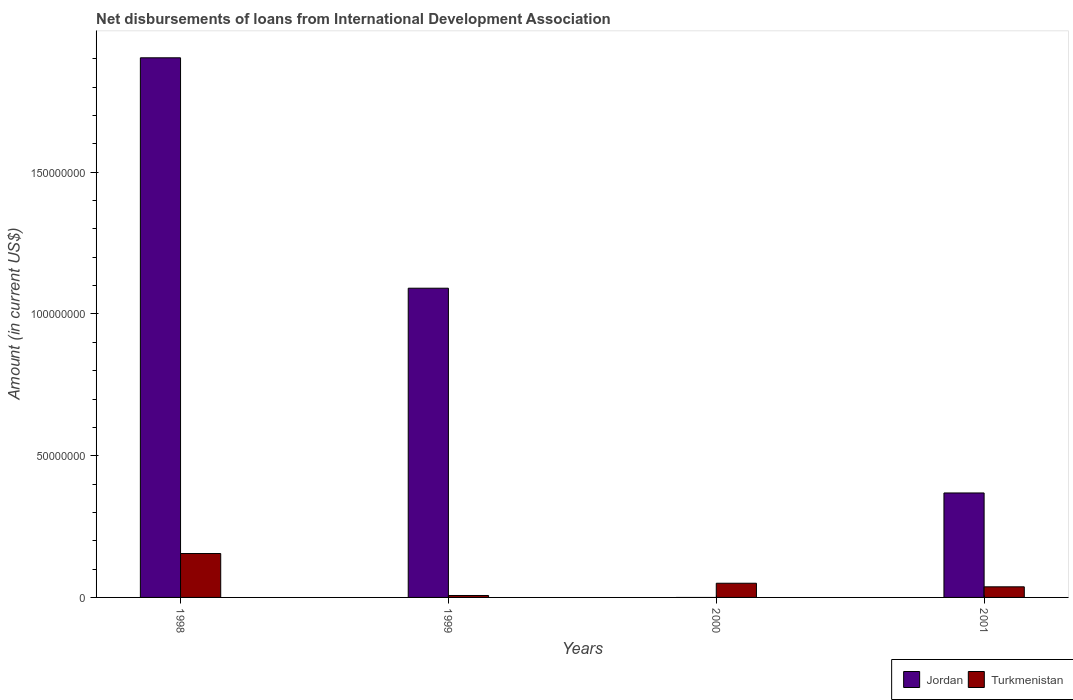How many different coloured bars are there?
Offer a very short reply. 2. Are the number of bars per tick equal to the number of legend labels?
Keep it short and to the point. No. Are the number of bars on each tick of the X-axis equal?
Your answer should be compact. No. How many bars are there on the 4th tick from the left?
Your answer should be compact. 2. How many bars are there on the 2nd tick from the right?
Ensure brevity in your answer.  1. In how many cases, is the number of bars for a given year not equal to the number of legend labels?
Give a very brief answer. 1. What is the amount of loans disbursed in Turkmenistan in 2001?
Make the answer very short. 3.74e+06. Across all years, what is the maximum amount of loans disbursed in Turkmenistan?
Offer a very short reply. 1.55e+07. Across all years, what is the minimum amount of loans disbursed in Turkmenistan?
Offer a terse response. 6.84e+05. In which year was the amount of loans disbursed in Turkmenistan maximum?
Provide a short and direct response. 1998. What is the total amount of loans disbursed in Jordan in the graph?
Your response must be concise. 3.36e+08. What is the difference between the amount of loans disbursed in Turkmenistan in 1999 and that in 2001?
Keep it short and to the point. -3.06e+06. What is the difference between the amount of loans disbursed in Jordan in 2001 and the amount of loans disbursed in Turkmenistan in 1999?
Provide a succinct answer. 3.62e+07. What is the average amount of loans disbursed in Jordan per year?
Give a very brief answer. 8.41e+07. In the year 1999, what is the difference between the amount of loans disbursed in Jordan and amount of loans disbursed in Turkmenistan?
Make the answer very short. 1.08e+08. In how many years, is the amount of loans disbursed in Turkmenistan greater than 110000000 US$?
Offer a very short reply. 0. What is the ratio of the amount of loans disbursed in Jordan in 1998 to that in 1999?
Make the answer very short. 1.75. Is the amount of loans disbursed in Turkmenistan in 2000 less than that in 2001?
Your answer should be very brief. No. Is the difference between the amount of loans disbursed in Jordan in 1998 and 1999 greater than the difference between the amount of loans disbursed in Turkmenistan in 1998 and 1999?
Your response must be concise. Yes. What is the difference between the highest and the second highest amount of loans disbursed in Turkmenistan?
Offer a very short reply. 1.05e+07. What is the difference between the highest and the lowest amount of loans disbursed in Jordan?
Provide a succinct answer. 1.90e+08. In how many years, is the amount of loans disbursed in Jordan greater than the average amount of loans disbursed in Jordan taken over all years?
Your answer should be compact. 2. How many bars are there?
Your response must be concise. 7. Are all the bars in the graph horizontal?
Make the answer very short. No. Where does the legend appear in the graph?
Your answer should be compact. Bottom right. What is the title of the graph?
Your answer should be compact. Net disbursements of loans from International Development Association. What is the label or title of the Y-axis?
Provide a succinct answer. Amount (in current US$). What is the Amount (in current US$) of Jordan in 1998?
Keep it short and to the point. 1.90e+08. What is the Amount (in current US$) of Turkmenistan in 1998?
Give a very brief answer. 1.55e+07. What is the Amount (in current US$) of Jordan in 1999?
Keep it short and to the point. 1.09e+08. What is the Amount (in current US$) in Turkmenistan in 1999?
Ensure brevity in your answer.  6.84e+05. What is the Amount (in current US$) in Turkmenistan in 2000?
Your answer should be very brief. 5.00e+06. What is the Amount (in current US$) of Jordan in 2001?
Keep it short and to the point. 3.69e+07. What is the Amount (in current US$) in Turkmenistan in 2001?
Your answer should be compact. 3.74e+06. Across all years, what is the maximum Amount (in current US$) in Jordan?
Keep it short and to the point. 1.90e+08. Across all years, what is the maximum Amount (in current US$) of Turkmenistan?
Your answer should be compact. 1.55e+07. Across all years, what is the minimum Amount (in current US$) in Turkmenistan?
Provide a succinct answer. 6.84e+05. What is the total Amount (in current US$) of Jordan in the graph?
Keep it short and to the point. 3.36e+08. What is the total Amount (in current US$) of Turkmenistan in the graph?
Your response must be concise. 2.49e+07. What is the difference between the Amount (in current US$) of Jordan in 1998 and that in 1999?
Offer a very short reply. 8.13e+07. What is the difference between the Amount (in current US$) of Turkmenistan in 1998 and that in 1999?
Offer a very short reply. 1.48e+07. What is the difference between the Amount (in current US$) in Turkmenistan in 1998 and that in 2000?
Your response must be concise. 1.05e+07. What is the difference between the Amount (in current US$) in Jordan in 1998 and that in 2001?
Provide a succinct answer. 1.54e+08. What is the difference between the Amount (in current US$) of Turkmenistan in 1998 and that in 2001?
Your response must be concise. 1.17e+07. What is the difference between the Amount (in current US$) in Turkmenistan in 1999 and that in 2000?
Your answer should be very brief. -4.32e+06. What is the difference between the Amount (in current US$) in Jordan in 1999 and that in 2001?
Your answer should be very brief. 7.22e+07. What is the difference between the Amount (in current US$) in Turkmenistan in 1999 and that in 2001?
Offer a very short reply. -3.06e+06. What is the difference between the Amount (in current US$) of Turkmenistan in 2000 and that in 2001?
Make the answer very short. 1.26e+06. What is the difference between the Amount (in current US$) of Jordan in 1998 and the Amount (in current US$) of Turkmenistan in 1999?
Offer a very short reply. 1.90e+08. What is the difference between the Amount (in current US$) in Jordan in 1998 and the Amount (in current US$) in Turkmenistan in 2000?
Offer a very short reply. 1.85e+08. What is the difference between the Amount (in current US$) in Jordan in 1998 and the Amount (in current US$) in Turkmenistan in 2001?
Your answer should be very brief. 1.87e+08. What is the difference between the Amount (in current US$) of Jordan in 1999 and the Amount (in current US$) of Turkmenistan in 2000?
Your response must be concise. 1.04e+08. What is the difference between the Amount (in current US$) in Jordan in 1999 and the Amount (in current US$) in Turkmenistan in 2001?
Give a very brief answer. 1.05e+08. What is the average Amount (in current US$) in Jordan per year?
Give a very brief answer. 8.41e+07. What is the average Amount (in current US$) in Turkmenistan per year?
Your response must be concise. 6.23e+06. In the year 1998, what is the difference between the Amount (in current US$) in Jordan and Amount (in current US$) in Turkmenistan?
Provide a succinct answer. 1.75e+08. In the year 1999, what is the difference between the Amount (in current US$) in Jordan and Amount (in current US$) in Turkmenistan?
Offer a terse response. 1.08e+08. In the year 2001, what is the difference between the Amount (in current US$) of Jordan and Amount (in current US$) of Turkmenistan?
Your answer should be compact. 3.31e+07. What is the ratio of the Amount (in current US$) of Jordan in 1998 to that in 1999?
Make the answer very short. 1.75. What is the ratio of the Amount (in current US$) of Turkmenistan in 1998 to that in 1999?
Provide a short and direct response. 22.65. What is the ratio of the Amount (in current US$) in Turkmenistan in 1998 to that in 2000?
Your answer should be compact. 3.1. What is the ratio of the Amount (in current US$) of Jordan in 1998 to that in 2001?
Your answer should be compact. 5.17. What is the ratio of the Amount (in current US$) of Turkmenistan in 1998 to that in 2001?
Offer a very short reply. 4.14. What is the ratio of the Amount (in current US$) of Turkmenistan in 1999 to that in 2000?
Give a very brief answer. 0.14. What is the ratio of the Amount (in current US$) in Jordan in 1999 to that in 2001?
Give a very brief answer. 2.96. What is the ratio of the Amount (in current US$) of Turkmenistan in 1999 to that in 2001?
Your response must be concise. 0.18. What is the ratio of the Amount (in current US$) of Turkmenistan in 2000 to that in 2001?
Offer a very short reply. 1.34. What is the difference between the highest and the second highest Amount (in current US$) of Jordan?
Your response must be concise. 8.13e+07. What is the difference between the highest and the second highest Amount (in current US$) of Turkmenistan?
Offer a very short reply. 1.05e+07. What is the difference between the highest and the lowest Amount (in current US$) of Jordan?
Give a very brief answer. 1.90e+08. What is the difference between the highest and the lowest Amount (in current US$) in Turkmenistan?
Your response must be concise. 1.48e+07. 